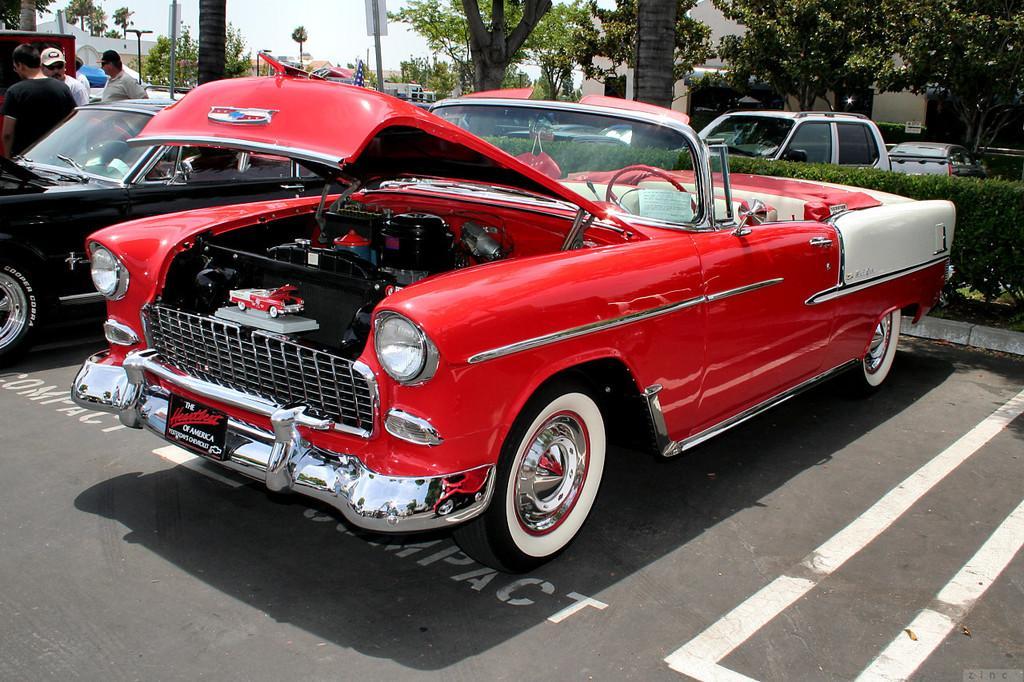How would you summarize this image in a sentence or two? In this image we can see cars on the road. On the left there are people. In the background there are trees, poles, buildings and sky. 